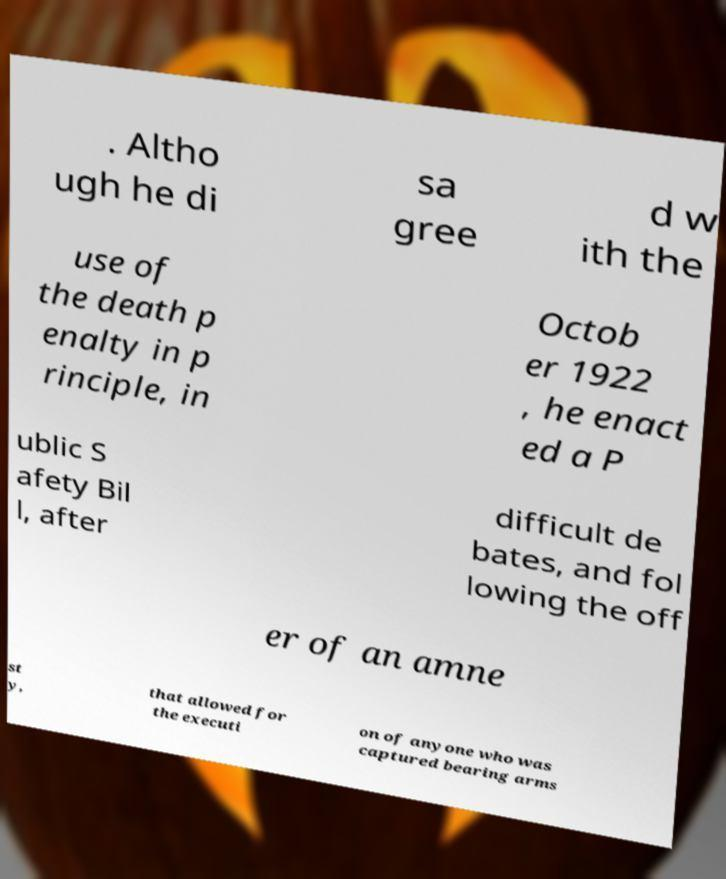Please identify and transcribe the text found in this image. . Altho ugh he di sa gree d w ith the use of the death p enalty in p rinciple, in Octob er 1922 , he enact ed a P ublic S afety Bil l, after difficult de bates, and fol lowing the off er of an amne st y, that allowed for the executi on of anyone who was captured bearing arms 